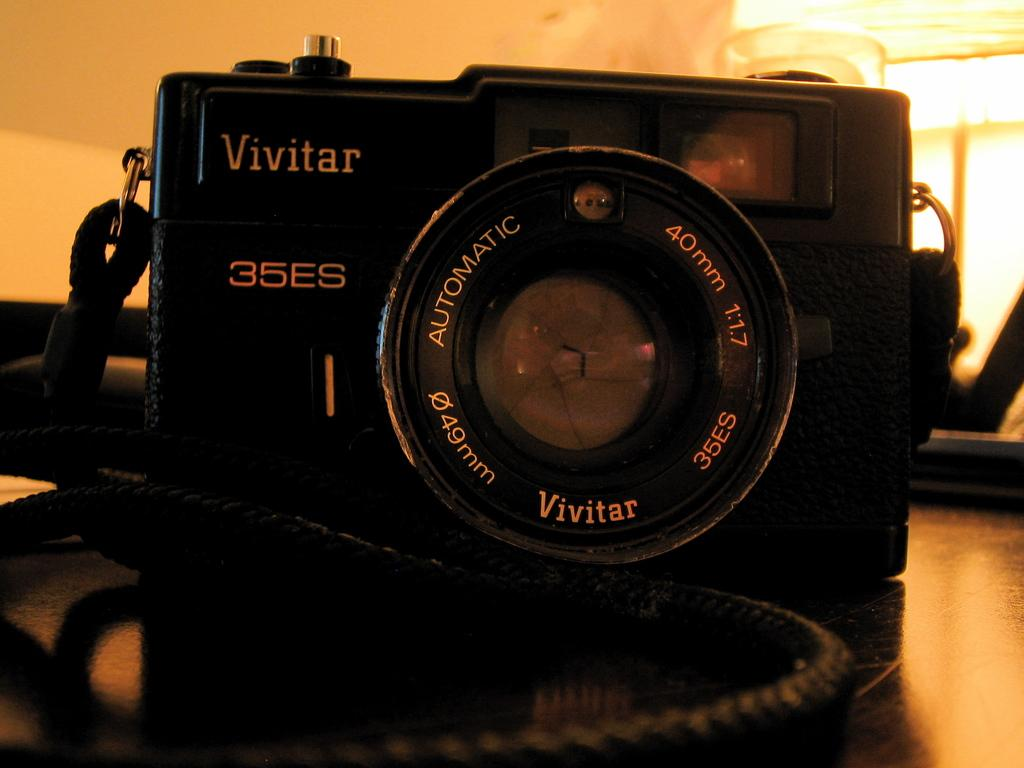What is the main subject of the image? The main subject of the image is a camera. What is the color of the camera? The camera is black in color. What feature can be seen at the top of the camera? There are lights at the top of the camera. How much sugar is required to operate the camera in the image? There is no sugar involved in operating the camera in the image; it is an electronic device. 